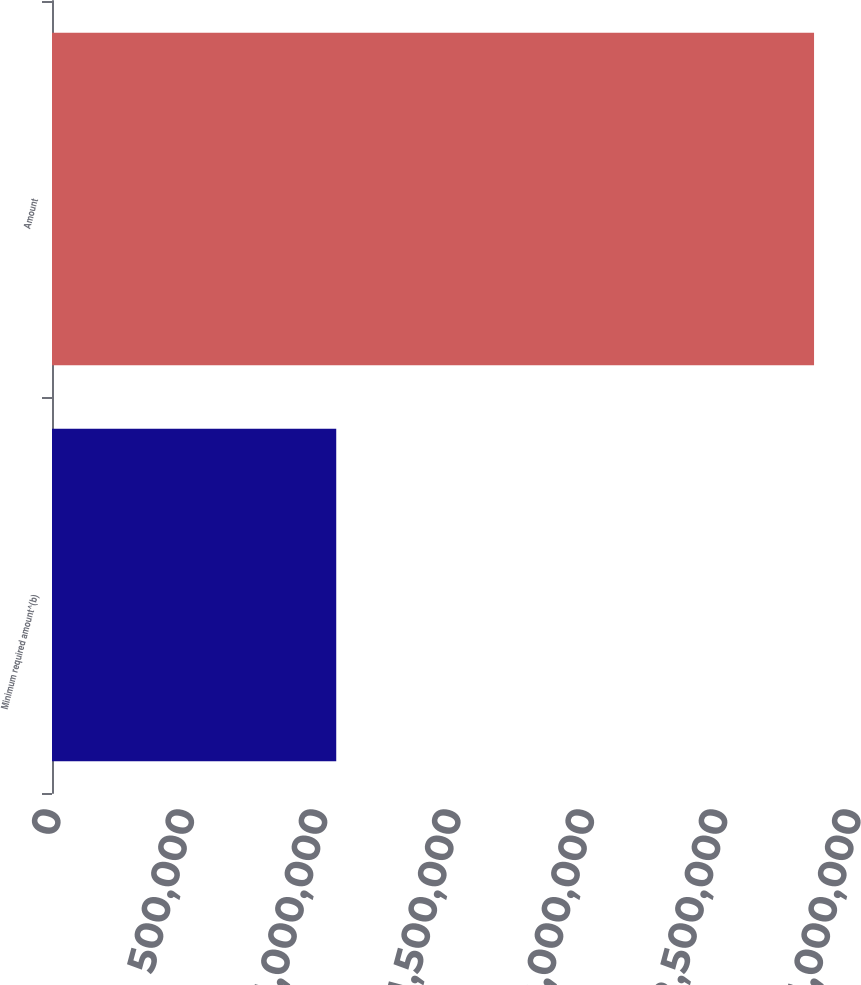Convert chart to OTSL. <chart><loc_0><loc_0><loc_500><loc_500><bar_chart><fcel>Minimum required amount^(b)<fcel>Amount<nl><fcel>1.06588e+06<fcel>2.85769e+06<nl></chart> 